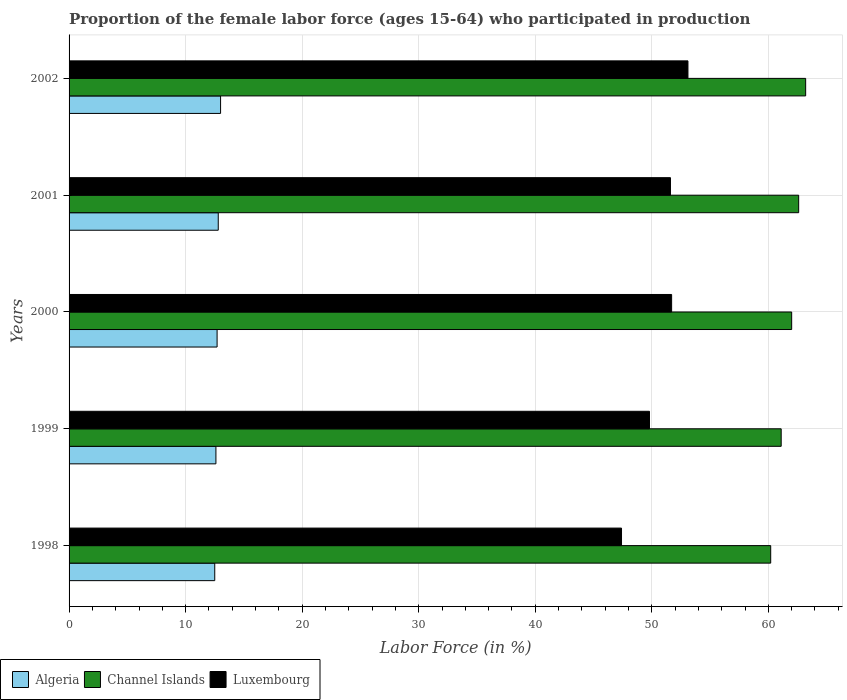How many groups of bars are there?
Your response must be concise. 5. Are the number of bars per tick equal to the number of legend labels?
Ensure brevity in your answer.  Yes. How many bars are there on the 5th tick from the bottom?
Ensure brevity in your answer.  3. In how many cases, is the number of bars for a given year not equal to the number of legend labels?
Offer a terse response. 0. What is the proportion of the female labor force who participated in production in Luxembourg in 1998?
Your answer should be compact. 47.4. Across all years, what is the maximum proportion of the female labor force who participated in production in Channel Islands?
Offer a very short reply. 63.2. In which year was the proportion of the female labor force who participated in production in Channel Islands maximum?
Give a very brief answer. 2002. In which year was the proportion of the female labor force who participated in production in Algeria minimum?
Keep it short and to the point. 1998. What is the total proportion of the female labor force who participated in production in Channel Islands in the graph?
Give a very brief answer. 309.1. What is the difference between the proportion of the female labor force who participated in production in Luxembourg in 2001 and the proportion of the female labor force who participated in production in Algeria in 1999?
Offer a very short reply. 39. What is the average proportion of the female labor force who participated in production in Channel Islands per year?
Offer a terse response. 61.82. In the year 1998, what is the difference between the proportion of the female labor force who participated in production in Algeria and proportion of the female labor force who participated in production in Luxembourg?
Give a very brief answer. -34.9. In how many years, is the proportion of the female labor force who participated in production in Luxembourg greater than 2 %?
Provide a succinct answer. 5. What is the ratio of the proportion of the female labor force who participated in production in Luxembourg in 1998 to that in 2000?
Your answer should be compact. 0.92. Is the proportion of the female labor force who participated in production in Algeria in 2001 less than that in 2002?
Give a very brief answer. Yes. What is the difference between the highest and the second highest proportion of the female labor force who participated in production in Luxembourg?
Make the answer very short. 1.4. In how many years, is the proportion of the female labor force who participated in production in Algeria greater than the average proportion of the female labor force who participated in production in Algeria taken over all years?
Offer a terse response. 2. What does the 2nd bar from the top in 2002 represents?
Make the answer very short. Channel Islands. What does the 1st bar from the bottom in 2001 represents?
Give a very brief answer. Algeria. Is it the case that in every year, the sum of the proportion of the female labor force who participated in production in Algeria and proportion of the female labor force who participated in production in Channel Islands is greater than the proportion of the female labor force who participated in production in Luxembourg?
Make the answer very short. Yes. How many bars are there?
Offer a terse response. 15. Are all the bars in the graph horizontal?
Your response must be concise. Yes. How many years are there in the graph?
Provide a short and direct response. 5. Are the values on the major ticks of X-axis written in scientific E-notation?
Your answer should be compact. No. Does the graph contain any zero values?
Your response must be concise. No. How many legend labels are there?
Give a very brief answer. 3. How are the legend labels stacked?
Keep it short and to the point. Horizontal. What is the title of the graph?
Ensure brevity in your answer.  Proportion of the female labor force (ages 15-64) who participated in production. What is the Labor Force (in %) in Channel Islands in 1998?
Provide a short and direct response. 60.2. What is the Labor Force (in %) of Luxembourg in 1998?
Ensure brevity in your answer.  47.4. What is the Labor Force (in %) of Algeria in 1999?
Provide a succinct answer. 12.6. What is the Labor Force (in %) of Channel Islands in 1999?
Offer a terse response. 61.1. What is the Labor Force (in %) of Luxembourg in 1999?
Keep it short and to the point. 49.8. What is the Labor Force (in %) of Algeria in 2000?
Your answer should be compact. 12.7. What is the Labor Force (in %) in Luxembourg in 2000?
Provide a short and direct response. 51.7. What is the Labor Force (in %) in Algeria in 2001?
Give a very brief answer. 12.8. What is the Labor Force (in %) in Channel Islands in 2001?
Make the answer very short. 62.6. What is the Labor Force (in %) of Luxembourg in 2001?
Keep it short and to the point. 51.6. What is the Labor Force (in %) in Algeria in 2002?
Ensure brevity in your answer.  13. What is the Labor Force (in %) of Channel Islands in 2002?
Your answer should be very brief. 63.2. What is the Labor Force (in %) of Luxembourg in 2002?
Keep it short and to the point. 53.1. Across all years, what is the maximum Labor Force (in %) in Algeria?
Ensure brevity in your answer.  13. Across all years, what is the maximum Labor Force (in %) in Channel Islands?
Make the answer very short. 63.2. Across all years, what is the maximum Labor Force (in %) of Luxembourg?
Ensure brevity in your answer.  53.1. Across all years, what is the minimum Labor Force (in %) in Algeria?
Make the answer very short. 12.5. Across all years, what is the minimum Labor Force (in %) in Channel Islands?
Offer a very short reply. 60.2. Across all years, what is the minimum Labor Force (in %) of Luxembourg?
Offer a terse response. 47.4. What is the total Labor Force (in %) of Algeria in the graph?
Keep it short and to the point. 63.6. What is the total Labor Force (in %) in Channel Islands in the graph?
Make the answer very short. 309.1. What is the total Labor Force (in %) of Luxembourg in the graph?
Your response must be concise. 253.6. What is the difference between the Labor Force (in %) in Algeria in 1998 and that in 1999?
Provide a succinct answer. -0.1. What is the difference between the Labor Force (in %) of Luxembourg in 1998 and that in 2000?
Provide a succinct answer. -4.3. What is the difference between the Labor Force (in %) of Channel Islands in 1998 and that in 2001?
Provide a succinct answer. -2.4. What is the difference between the Labor Force (in %) of Channel Islands in 1998 and that in 2002?
Keep it short and to the point. -3. What is the difference between the Labor Force (in %) of Luxembourg in 1998 and that in 2002?
Ensure brevity in your answer.  -5.7. What is the difference between the Labor Force (in %) in Channel Islands in 1999 and that in 2000?
Your response must be concise. -0.9. What is the difference between the Labor Force (in %) of Channel Islands in 1999 and that in 2001?
Offer a very short reply. -1.5. What is the difference between the Labor Force (in %) of Algeria in 1999 and that in 2002?
Your answer should be very brief. -0.4. What is the difference between the Labor Force (in %) of Channel Islands in 1999 and that in 2002?
Your answer should be compact. -2.1. What is the difference between the Labor Force (in %) of Luxembourg in 2000 and that in 2001?
Give a very brief answer. 0.1. What is the difference between the Labor Force (in %) of Channel Islands in 2000 and that in 2002?
Make the answer very short. -1.2. What is the difference between the Labor Force (in %) in Luxembourg in 2000 and that in 2002?
Provide a succinct answer. -1.4. What is the difference between the Labor Force (in %) of Channel Islands in 2001 and that in 2002?
Your answer should be very brief. -0.6. What is the difference between the Labor Force (in %) of Luxembourg in 2001 and that in 2002?
Ensure brevity in your answer.  -1.5. What is the difference between the Labor Force (in %) of Algeria in 1998 and the Labor Force (in %) of Channel Islands in 1999?
Provide a short and direct response. -48.6. What is the difference between the Labor Force (in %) in Algeria in 1998 and the Labor Force (in %) in Luxembourg in 1999?
Give a very brief answer. -37.3. What is the difference between the Labor Force (in %) of Algeria in 1998 and the Labor Force (in %) of Channel Islands in 2000?
Make the answer very short. -49.5. What is the difference between the Labor Force (in %) in Algeria in 1998 and the Labor Force (in %) in Luxembourg in 2000?
Offer a very short reply. -39.2. What is the difference between the Labor Force (in %) of Channel Islands in 1998 and the Labor Force (in %) of Luxembourg in 2000?
Your response must be concise. 8.5. What is the difference between the Labor Force (in %) in Algeria in 1998 and the Labor Force (in %) in Channel Islands in 2001?
Provide a succinct answer. -50.1. What is the difference between the Labor Force (in %) in Algeria in 1998 and the Labor Force (in %) in Luxembourg in 2001?
Keep it short and to the point. -39.1. What is the difference between the Labor Force (in %) in Algeria in 1998 and the Labor Force (in %) in Channel Islands in 2002?
Provide a short and direct response. -50.7. What is the difference between the Labor Force (in %) of Algeria in 1998 and the Labor Force (in %) of Luxembourg in 2002?
Offer a terse response. -40.6. What is the difference between the Labor Force (in %) of Channel Islands in 1998 and the Labor Force (in %) of Luxembourg in 2002?
Ensure brevity in your answer.  7.1. What is the difference between the Labor Force (in %) of Algeria in 1999 and the Labor Force (in %) of Channel Islands in 2000?
Ensure brevity in your answer.  -49.4. What is the difference between the Labor Force (in %) in Algeria in 1999 and the Labor Force (in %) in Luxembourg in 2000?
Keep it short and to the point. -39.1. What is the difference between the Labor Force (in %) in Algeria in 1999 and the Labor Force (in %) in Luxembourg in 2001?
Your response must be concise. -39. What is the difference between the Labor Force (in %) of Channel Islands in 1999 and the Labor Force (in %) of Luxembourg in 2001?
Make the answer very short. 9.5. What is the difference between the Labor Force (in %) of Algeria in 1999 and the Labor Force (in %) of Channel Islands in 2002?
Your response must be concise. -50.6. What is the difference between the Labor Force (in %) of Algeria in 1999 and the Labor Force (in %) of Luxembourg in 2002?
Provide a short and direct response. -40.5. What is the difference between the Labor Force (in %) in Channel Islands in 1999 and the Labor Force (in %) in Luxembourg in 2002?
Your response must be concise. 8. What is the difference between the Labor Force (in %) of Algeria in 2000 and the Labor Force (in %) of Channel Islands in 2001?
Your answer should be compact. -49.9. What is the difference between the Labor Force (in %) in Algeria in 2000 and the Labor Force (in %) in Luxembourg in 2001?
Provide a succinct answer. -38.9. What is the difference between the Labor Force (in %) in Algeria in 2000 and the Labor Force (in %) in Channel Islands in 2002?
Your answer should be compact. -50.5. What is the difference between the Labor Force (in %) in Algeria in 2000 and the Labor Force (in %) in Luxembourg in 2002?
Keep it short and to the point. -40.4. What is the difference between the Labor Force (in %) of Algeria in 2001 and the Labor Force (in %) of Channel Islands in 2002?
Provide a succinct answer. -50.4. What is the difference between the Labor Force (in %) in Algeria in 2001 and the Labor Force (in %) in Luxembourg in 2002?
Give a very brief answer. -40.3. What is the difference between the Labor Force (in %) in Channel Islands in 2001 and the Labor Force (in %) in Luxembourg in 2002?
Make the answer very short. 9.5. What is the average Labor Force (in %) of Algeria per year?
Ensure brevity in your answer.  12.72. What is the average Labor Force (in %) of Channel Islands per year?
Offer a terse response. 61.82. What is the average Labor Force (in %) of Luxembourg per year?
Ensure brevity in your answer.  50.72. In the year 1998, what is the difference between the Labor Force (in %) in Algeria and Labor Force (in %) in Channel Islands?
Ensure brevity in your answer.  -47.7. In the year 1998, what is the difference between the Labor Force (in %) of Algeria and Labor Force (in %) of Luxembourg?
Provide a succinct answer. -34.9. In the year 1999, what is the difference between the Labor Force (in %) in Algeria and Labor Force (in %) in Channel Islands?
Offer a very short reply. -48.5. In the year 1999, what is the difference between the Labor Force (in %) in Algeria and Labor Force (in %) in Luxembourg?
Make the answer very short. -37.2. In the year 2000, what is the difference between the Labor Force (in %) in Algeria and Labor Force (in %) in Channel Islands?
Your answer should be compact. -49.3. In the year 2000, what is the difference between the Labor Force (in %) in Algeria and Labor Force (in %) in Luxembourg?
Provide a succinct answer. -39. In the year 2000, what is the difference between the Labor Force (in %) in Channel Islands and Labor Force (in %) in Luxembourg?
Give a very brief answer. 10.3. In the year 2001, what is the difference between the Labor Force (in %) in Algeria and Labor Force (in %) in Channel Islands?
Make the answer very short. -49.8. In the year 2001, what is the difference between the Labor Force (in %) of Algeria and Labor Force (in %) of Luxembourg?
Make the answer very short. -38.8. In the year 2001, what is the difference between the Labor Force (in %) in Channel Islands and Labor Force (in %) in Luxembourg?
Your answer should be very brief. 11. In the year 2002, what is the difference between the Labor Force (in %) in Algeria and Labor Force (in %) in Channel Islands?
Give a very brief answer. -50.2. In the year 2002, what is the difference between the Labor Force (in %) of Algeria and Labor Force (in %) of Luxembourg?
Give a very brief answer. -40.1. What is the ratio of the Labor Force (in %) of Channel Islands in 1998 to that in 1999?
Ensure brevity in your answer.  0.99. What is the ratio of the Labor Force (in %) in Luxembourg in 1998 to that in 1999?
Provide a short and direct response. 0.95. What is the ratio of the Labor Force (in %) of Algeria in 1998 to that in 2000?
Provide a succinct answer. 0.98. What is the ratio of the Labor Force (in %) in Luxembourg in 1998 to that in 2000?
Offer a very short reply. 0.92. What is the ratio of the Labor Force (in %) in Algeria in 1998 to that in 2001?
Your answer should be compact. 0.98. What is the ratio of the Labor Force (in %) in Channel Islands in 1998 to that in 2001?
Offer a very short reply. 0.96. What is the ratio of the Labor Force (in %) of Luxembourg in 1998 to that in 2001?
Keep it short and to the point. 0.92. What is the ratio of the Labor Force (in %) in Algeria in 1998 to that in 2002?
Offer a very short reply. 0.96. What is the ratio of the Labor Force (in %) of Channel Islands in 1998 to that in 2002?
Offer a terse response. 0.95. What is the ratio of the Labor Force (in %) in Luxembourg in 1998 to that in 2002?
Offer a very short reply. 0.89. What is the ratio of the Labor Force (in %) of Channel Islands in 1999 to that in 2000?
Your answer should be very brief. 0.99. What is the ratio of the Labor Force (in %) in Luxembourg in 1999 to that in 2000?
Provide a succinct answer. 0.96. What is the ratio of the Labor Force (in %) of Algeria in 1999 to that in 2001?
Your answer should be compact. 0.98. What is the ratio of the Labor Force (in %) in Channel Islands in 1999 to that in 2001?
Provide a short and direct response. 0.98. What is the ratio of the Labor Force (in %) in Luxembourg in 1999 to that in 2001?
Ensure brevity in your answer.  0.97. What is the ratio of the Labor Force (in %) in Algeria in 1999 to that in 2002?
Provide a short and direct response. 0.97. What is the ratio of the Labor Force (in %) of Channel Islands in 1999 to that in 2002?
Provide a short and direct response. 0.97. What is the ratio of the Labor Force (in %) in Luxembourg in 1999 to that in 2002?
Your answer should be very brief. 0.94. What is the ratio of the Labor Force (in %) in Algeria in 2000 to that in 2002?
Offer a terse response. 0.98. What is the ratio of the Labor Force (in %) of Channel Islands in 2000 to that in 2002?
Make the answer very short. 0.98. What is the ratio of the Labor Force (in %) in Luxembourg in 2000 to that in 2002?
Make the answer very short. 0.97. What is the ratio of the Labor Force (in %) of Algeria in 2001 to that in 2002?
Provide a short and direct response. 0.98. What is the ratio of the Labor Force (in %) of Luxembourg in 2001 to that in 2002?
Your response must be concise. 0.97. What is the difference between the highest and the second highest Labor Force (in %) of Algeria?
Your answer should be compact. 0.2. What is the difference between the highest and the lowest Labor Force (in %) in Channel Islands?
Give a very brief answer. 3. What is the difference between the highest and the lowest Labor Force (in %) of Luxembourg?
Your answer should be compact. 5.7. 